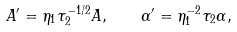Convert formula to latex. <formula><loc_0><loc_0><loc_500><loc_500>A ^ { \prime } = \eta _ { 1 } \tau _ { 2 } ^ { - 1 / 2 } A , \quad \alpha ^ { \prime } = \eta _ { 1 } ^ { - 2 } \tau _ { 2 } \alpha ,</formula> 